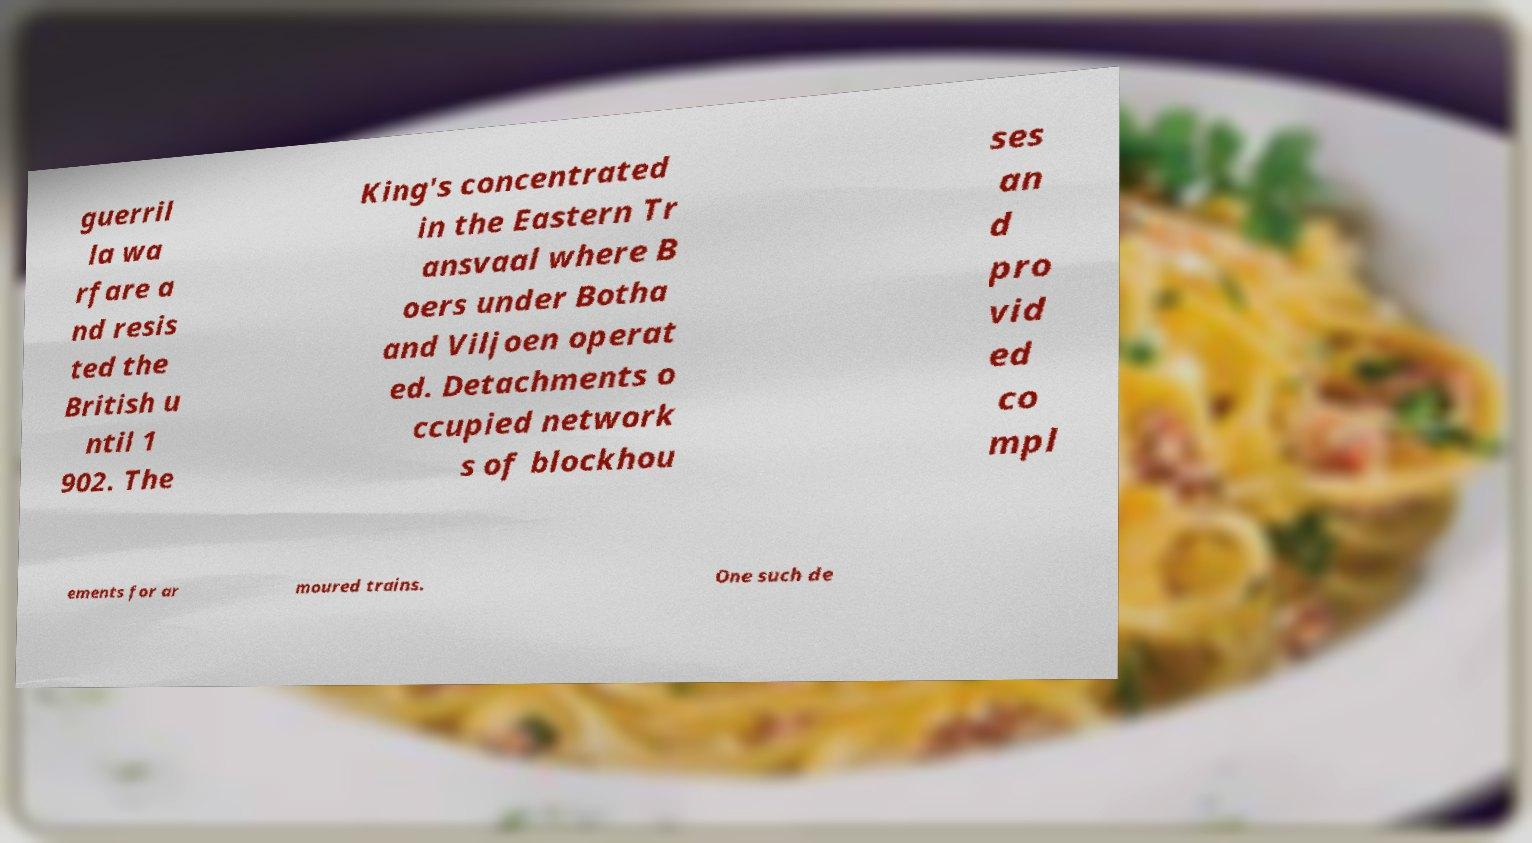What messages or text are displayed in this image? I need them in a readable, typed format. guerril la wa rfare a nd resis ted the British u ntil 1 902. The King's concentrated in the Eastern Tr ansvaal where B oers under Botha and Viljoen operat ed. Detachments o ccupied network s of blockhou ses an d pro vid ed co mpl ements for ar moured trains. One such de 